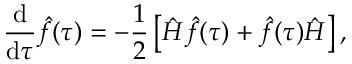Convert formula to latex. <formula><loc_0><loc_0><loc_500><loc_500>\frac { d } { d \tau } \hat { f } ( \tau ) = - \frac { 1 } { 2 } \left [ \hat { H } \hat { f } ( \tau ) + \hat { f } ( \tau ) \hat { H } \right ] ,</formula> 